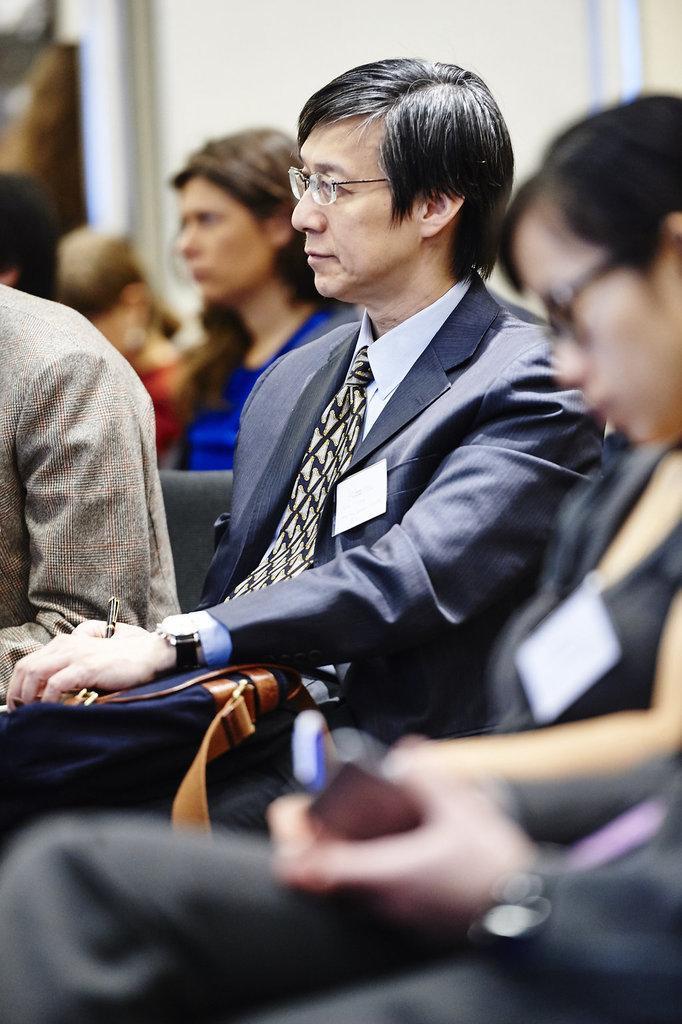Describe this image in one or two sentences. In the foreground of this image, there are four persons sitting and a man is holding a pen and a bag. In the background, there are few persons sitting and the white wall. 